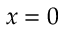Convert formula to latex. <formula><loc_0><loc_0><loc_500><loc_500>x = 0</formula> 